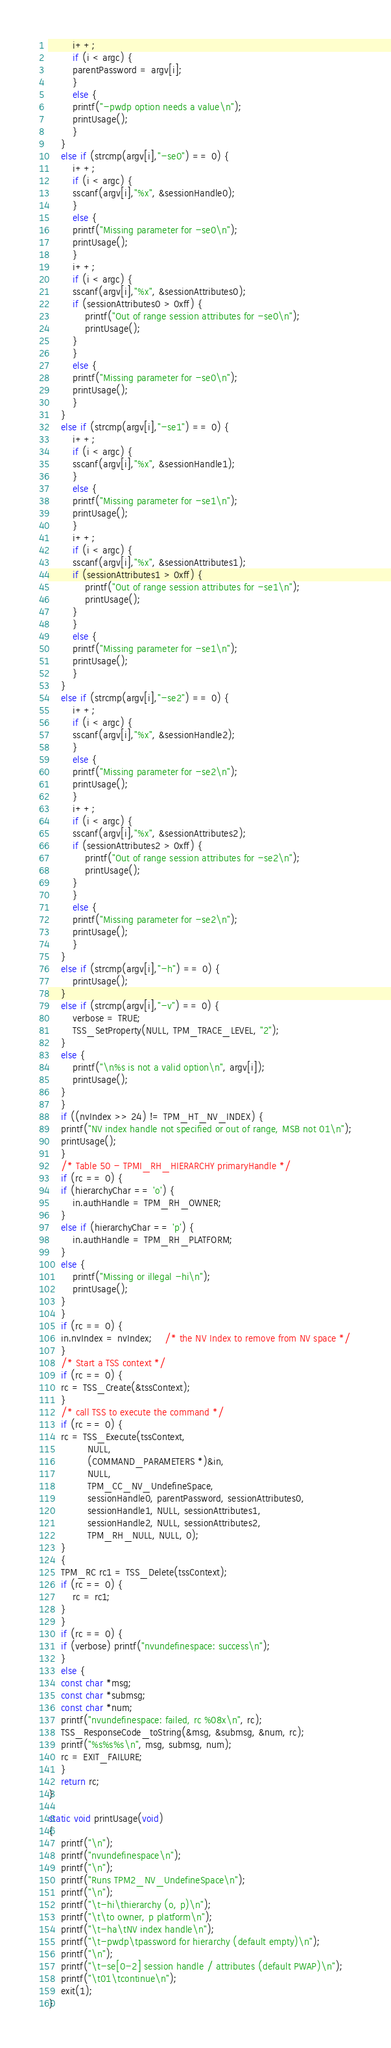Convert code to text. <code><loc_0><loc_0><loc_500><loc_500><_C_>	    i++;
	    if (i < argc) {
		parentPassword = argv[i];
	    }
	    else {
		printf("-pwdp option needs a value\n");
		printUsage();
	    }
	}
	else if (strcmp(argv[i],"-se0") == 0) {
	    i++;
	    if (i < argc) {
		sscanf(argv[i],"%x", &sessionHandle0);
	    }
	    else {
		printf("Missing parameter for -se0\n");
		printUsage();
	    }
	    i++;
	    if (i < argc) {
		sscanf(argv[i],"%x", &sessionAttributes0);
		if (sessionAttributes0 > 0xff) {
		    printf("Out of range session attributes for -se0\n");
		    printUsage();
		}
	    }
	    else {
		printf("Missing parameter for -se0\n");
		printUsage();
	    }
	}
	else if (strcmp(argv[i],"-se1") == 0) {
	    i++;
	    if (i < argc) {
		sscanf(argv[i],"%x", &sessionHandle1);
	    }
	    else {
		printf("Missing parameter for -se1\n");
		printUsage();
	    }
	    i++;
	    if (i < argc) {
		sscanf(argv[i],"%x", &sessionAttributes1);
		if (sessionAttributes1 > 0xff) {
		    printf("Out of range session attributes for -se1\n");
		    printUsage();
		}
	    }
	    else {
		printf("Missing parameter for -se1\n");
		printUsage();
	    }
	}
	else if (strcmp(argv[i],"-se2") == 0) {
	    i++;
	    if (i < argc) {
		sscanf(argv[i],"%x", &sessionHandle2);
	    }
	    else {
		printf("Missing parameter for -se2\n");
		printUsage();
	    }
	    i++;
	    if (i < argc) {
		sscanf(argv[i],"%x", &sessionAttributes2);
		if (sessionAttributes2 > 0xff) {
		    printf("Out of range session attributes for -se2\n");
		    printUsage();
		}
	    }
	    else {
		printf("Missing parameter for -se2\n");
		printUsage();
	    }
	}
	else if (strcmp(argv[i],"-h") == 0) {
	    printUsage();
	}
	else if (strcmp(argv[i],"-v") == 0) {
	    verbose = TRUE;
	    TSS_SetProperty(NULL, TPM_TRACE_LEVEL, "2");
	}
	else {
	    printf("\n%s is not a valid option\n", argv[i]);
	    printUsage();
	}
    }
    if ((nvIndex >> 24) != TPM_HT_NV_INDEX) {
	printf("NV index handle not specified or out of range, MSB not 01\n");
	printUsage();
    }
    /* Table 50 - TPMI_RH_HIERARCHY primaryHandle */
    if (rc == 0) {
	if (hierarchyChar == 'o') {
	    in.authHandle = TPM_RH_OWNER;
	}
	else if (hierarchyChar == 'p') {
	    in.authHandle = TPM_RH_PLATFORM;
	}
	else {
	    printf("Missing or illegal -hi\n");
	    printUsage();
	}
    }
    if (rc == 0) {
	in.nvIndex = nvIndex;	/* the NV Index to remove from NV space */
    }
    /* Start a TSS context */
    if (rc == 0) {
	rc = TSS_Create(&tssContext);
    }
    /* call TSS to execute the command */
    if (rc == 0) {
	rc = TSS_Execute(tssContext,
			 NULL,
			 (COMMAND_PARAMETERS *)&in,
			 NULL,
			 TPM_CC_NV_UndefineSpace,
			 sessionHandle0, parentPassword, sessionAttributes0,
			 sessionHandle1, NULL, sessionAttributes1,
			 sessionHandle2, NULL, sessionAttributes2,
			 TPM_RH_NULL, NULL, 0);
    }
    {
	TPM_RC rc1 = TSS_Delete(tssContext);
	if (rc == 0) {
	    rc = rc1;
	}
    }
    if (rc == 0) {
	if (verbose) printf("nvundefinespace: success\n");
    }
    else {
	const char *msg;
	const char *submsg;
	const char *num;
	printf("nvundefinespace: failed, rc %08x\n", rc);
	TSS_ResponseCode_toString(&msg, &submsg, &num, rc);
	printf("%s%s%s\n", msg, submsg, num);
	rc = EXIT_FAILURE;
    }
    return rc;
}

static void printUsage(void)
{
    printf("\n");
    printf("nvundefinespace\n");
    printf("\n");
    printf("Runs TPM2_NV_UndefineSpace\n");
    printf("\n");
    printf("\t-hi\thierarchy (o, p)\n");
    printf("\t\to owner, p platform\n");
    printf("\t-ha\tNV index handle\n");
    printf("\t-pwdp\tpassword for hierarchy (default empty)\n");
    printf("\n");
    printf("\t-se[0-2] session handle / attributes (default PWAP)\n");
    printf("\t01\tcontinue\n");
    exit(1);	
}
</code> 